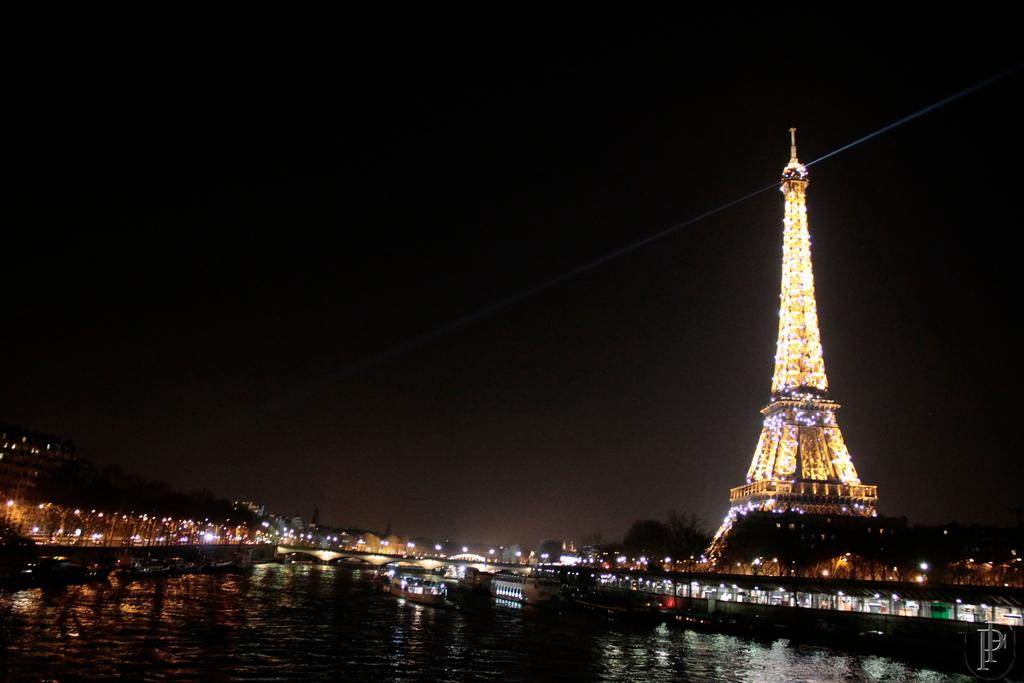What is the main structure in the image? There is a tower in the image. What natural feature can be seen in the image? There is a lake in the image. What type of man-made structures are present in the image? There are buildings in the image. What type of vegetation is present in the image? There are trees in the image. How would you describe the sky in the image? The sky is dark and clear in the image. How many birds are flying over the wrist in the image? There are no birds or wrists present in the image. 